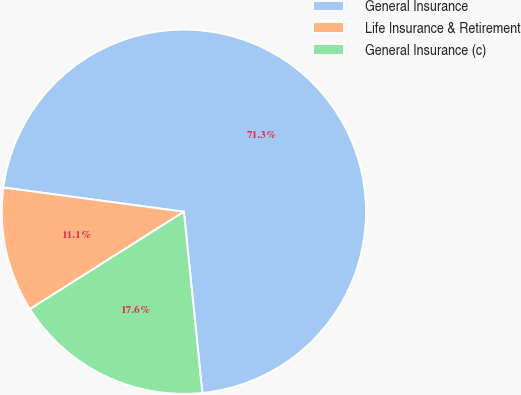Convert chart. <chart><loc_0><loc_0><loc_500><loc_500><pie_chart><fcel>General Insurance<fcel>Life Insurance & Retirement<fcel>General Insurance (c)<nl><fcel>71.26%<fcel>11.1%<fcel>17.64%<nl></chart> 